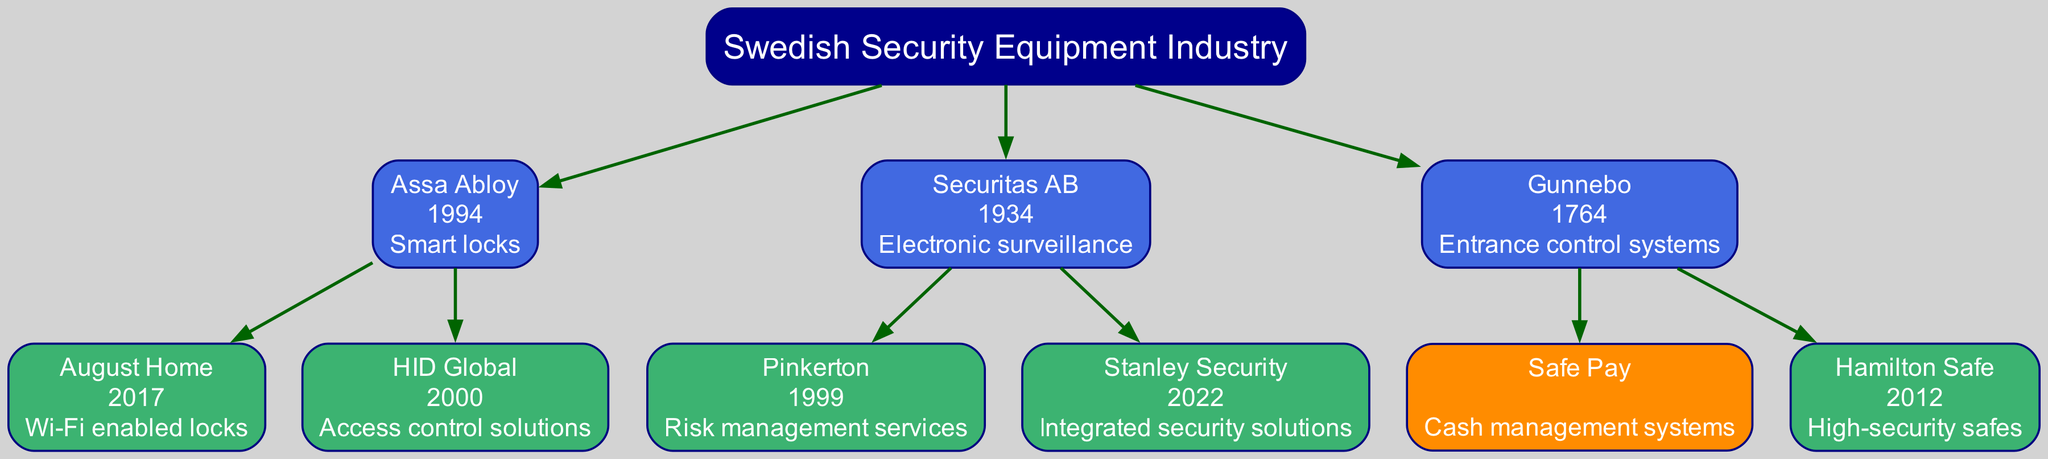What is the founding year of Gunnebo? The diagram indicates that Gunnebo was founded in 1764, as shown in its node label.
Answer: 1764 How many children does Assa Abloy have? Assa Abloy has two children, August Home and HID Global, as represented by the branches stemming from its node.
Answer: 2 What type of innovation is associated with Securitas AB? The diagram specifies that Securitas AB is associated with "Electronic surveillance," which is noted in its node.
Answer: Electronic surveillance Which company was acquired by Securitas AB in 1999? The diagram shows that Pinkerton was acquired by Securitas AB in 1999, as indicated next to the Pinkerton node.
Answer: Pinkerton What is the innovation developed by Safe Pay? According to the diagram, Safe Pay is associated with "Cash management systems," which is displayed in its node.
Answer: Cash management systems How many total companies are listed under the Swedish Security Equipment Industry? The diagram has a total of six companies, counting the root and all children and grandchildren nodes, as counted by navigating the hierarchy.
Answer: 6 What year was Stanley Security acquired by Securitas AB? The node for Stanley Security shows it was acquired in 2022, which is noted in its label within the diagram.
Answer: 2022 Which company's innovation includes "Wi-Fi enabled locks"? The diagram shows that August Home, a child of Assa Abloy, is associated with "Wi-Fi enabled locks" in its node description.
Answer: Wi-Fi enabled locks What is the relationship between Assa Abloy and HID Global? The diagram indicates that HID Global is a subsidiary of Assa Abloy, as expressively shown by the direct connection from Assa Abloy to HID Global.
Answer: Subsidiary 